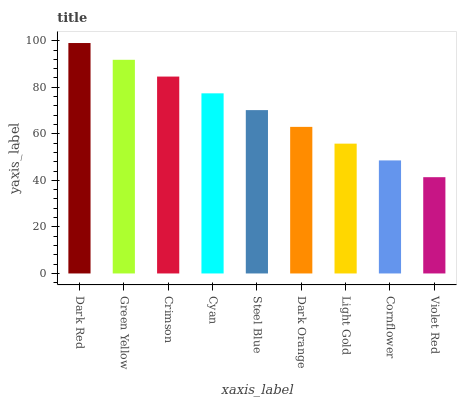Is Violet Red the minimum?
Answer yes or no. Yes. Is Dark Red the maximum?
Answer yes or no. Yes. Is Green Yellow the minimum?
Answer yes or no. No. Is Green Yellow the maximum?
Answer yes or no. No. Is Dark Red greater than Green Yellow?
Answer yes or no. Yes. Is Green Yellow less than Dark Red?
Answer yes or no. Yes. Is Green Yellow greater than Dark Red?
Answer yes or no. No. Is Dark Red less than Green Yellow?
Answer yes or no. No. Is Steel Blue the high median?
Answer yes or no. Yes. Is Steel Blue the low median?
Answer yes or no. Yes. Is Dark Orange the high median?
Answer yes or no. No. Is Cyan the low median?
Answer yes or no. No. 